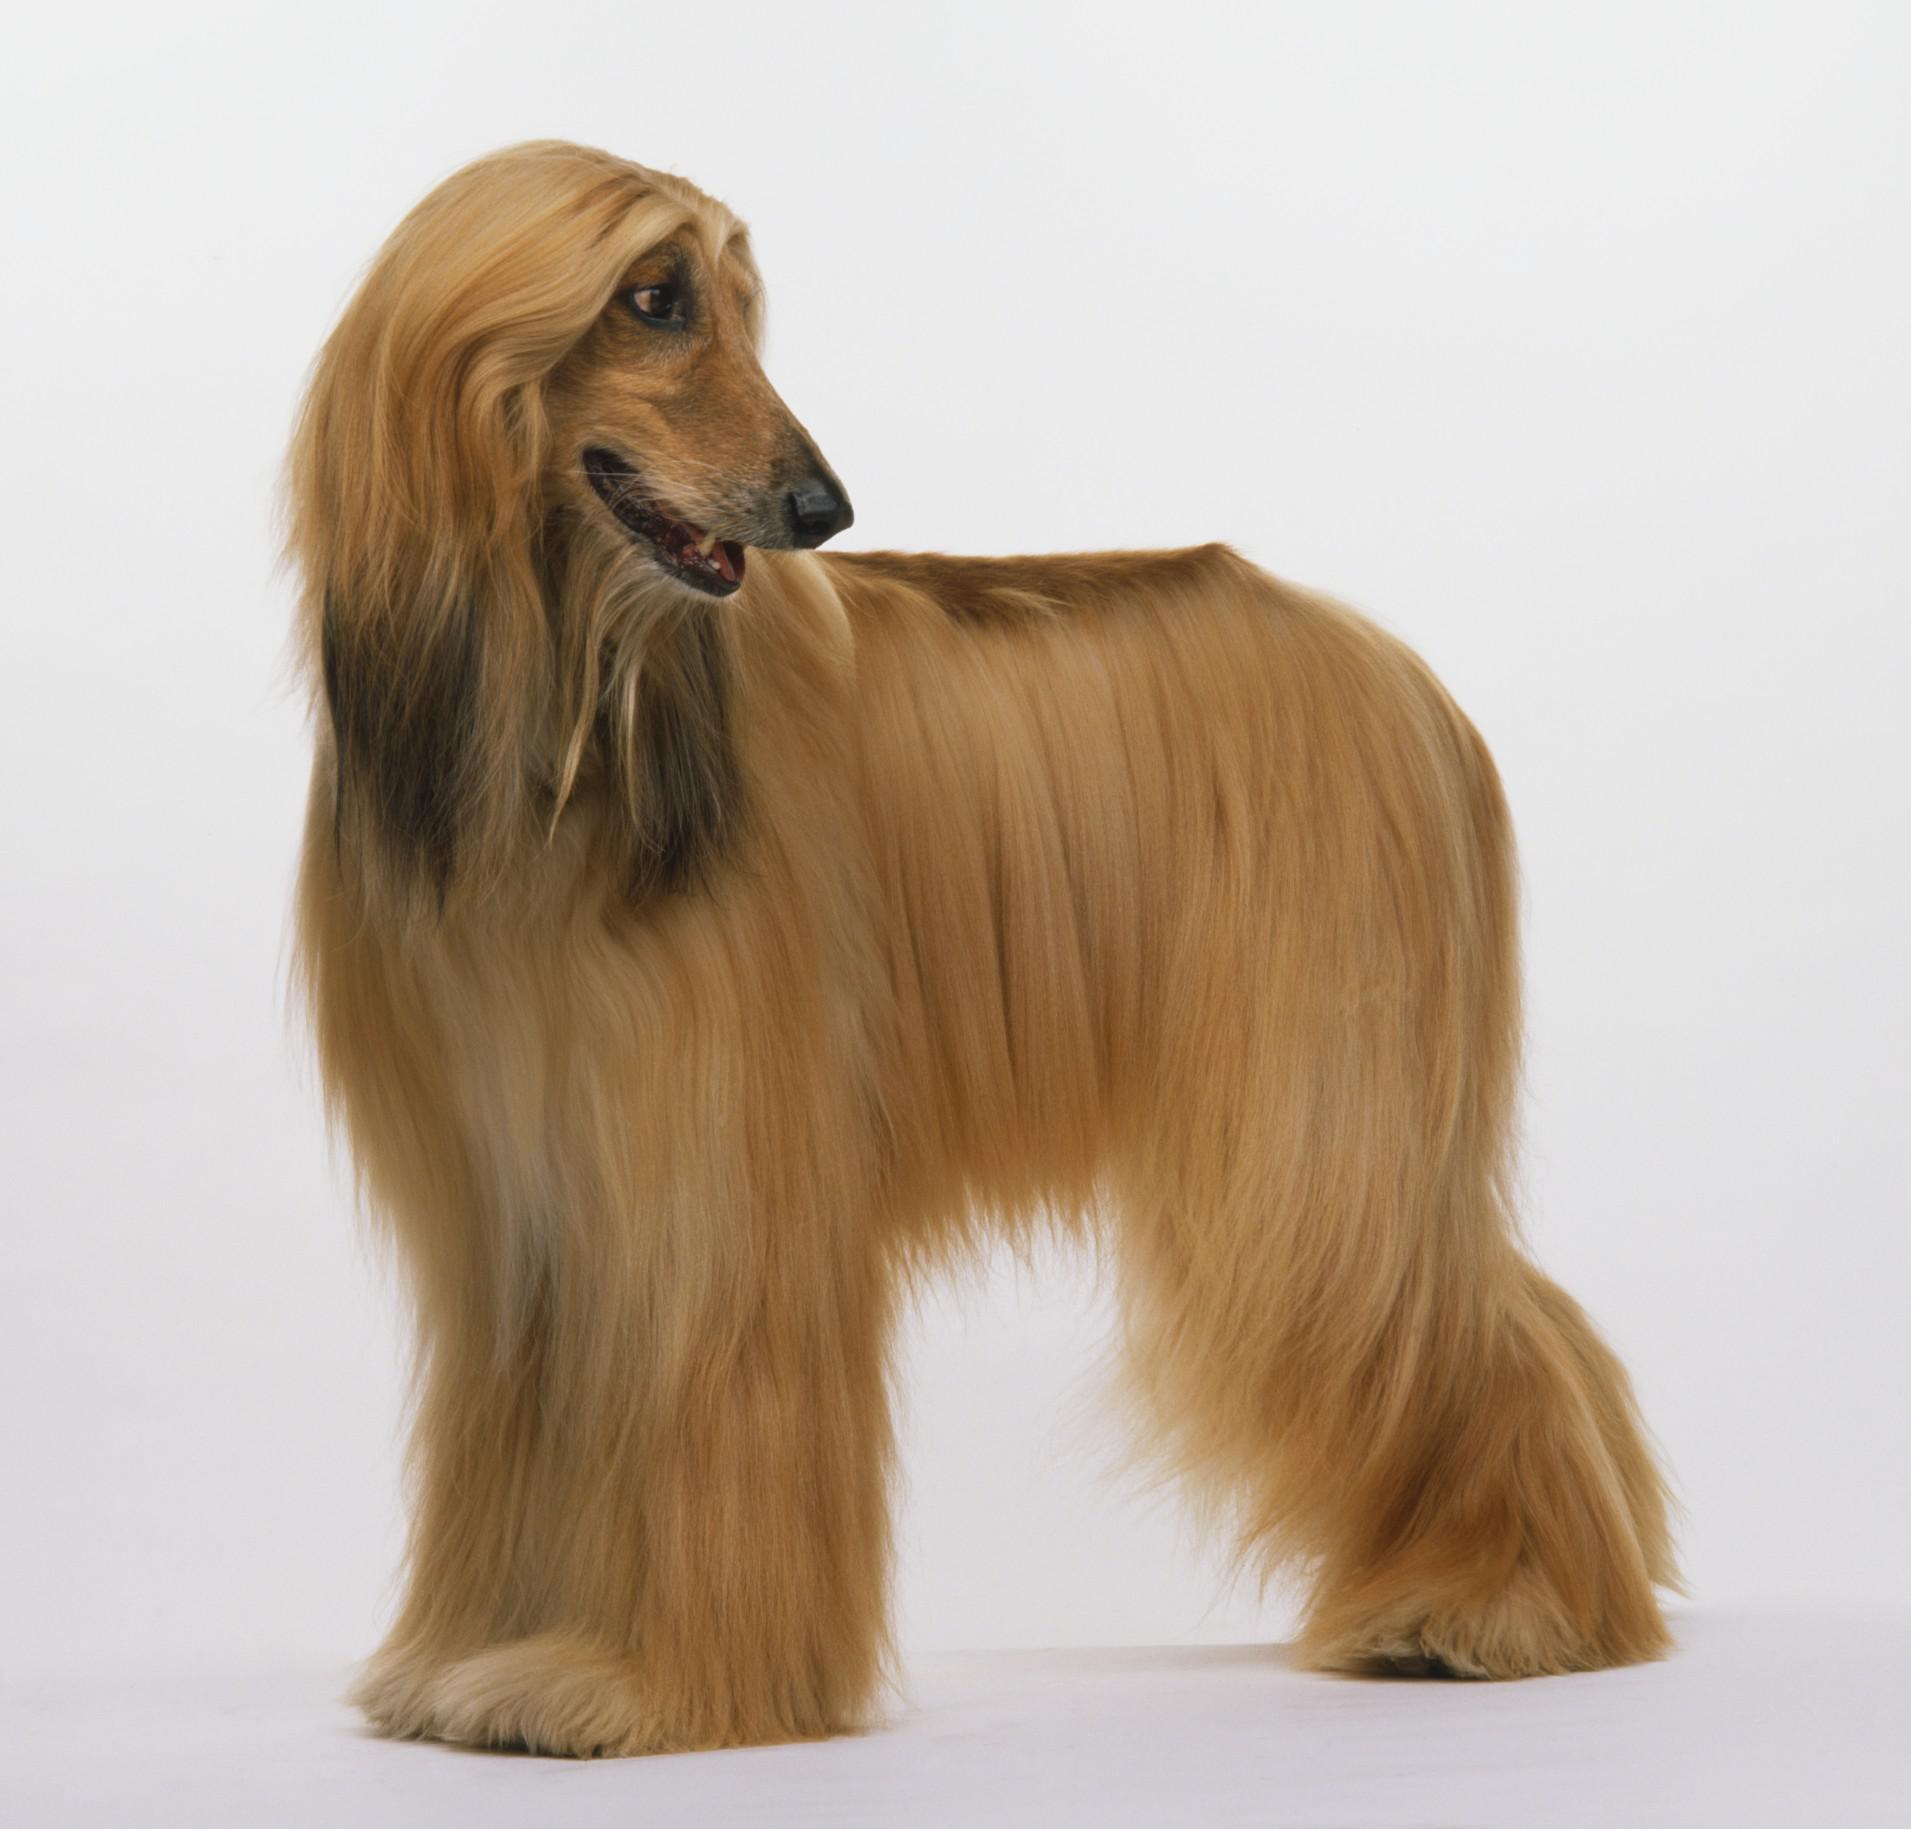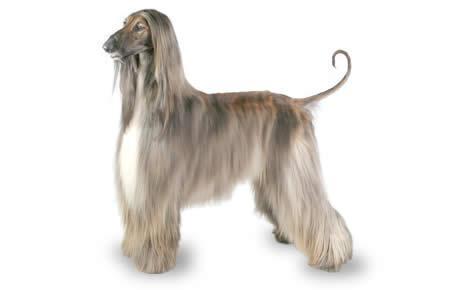The first image is the image on the left, the second image is the image on the right. Examine the images to the left and right. Is the description "There is a dog's face in the left image with greenery behind it." accurate? Answer yes or no. No. 